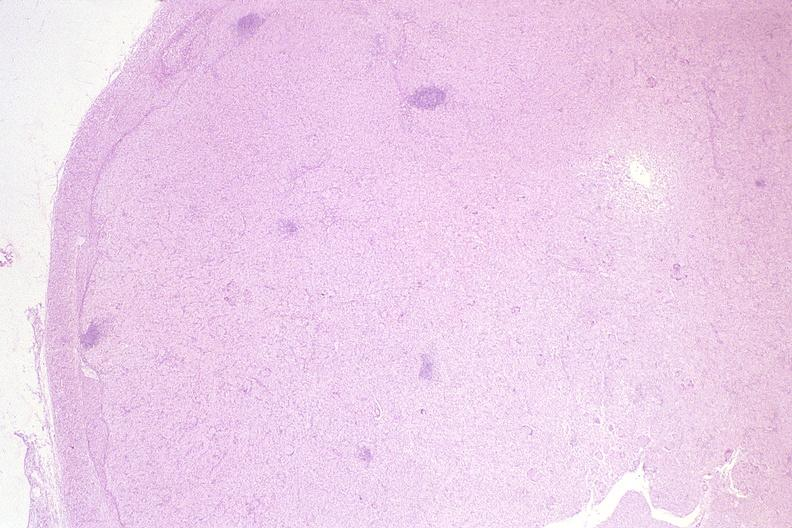what does this image show?
Answer the question using a single word or phrase. Lymph node 